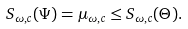<formula> <loc_0><loc_0><loc_500><loc_500>S _ { \omega , c } ( \Psi ) = \mu _ { \omega , c } \leq S _ { \omega , c } ( \Theta ) .</formula> 